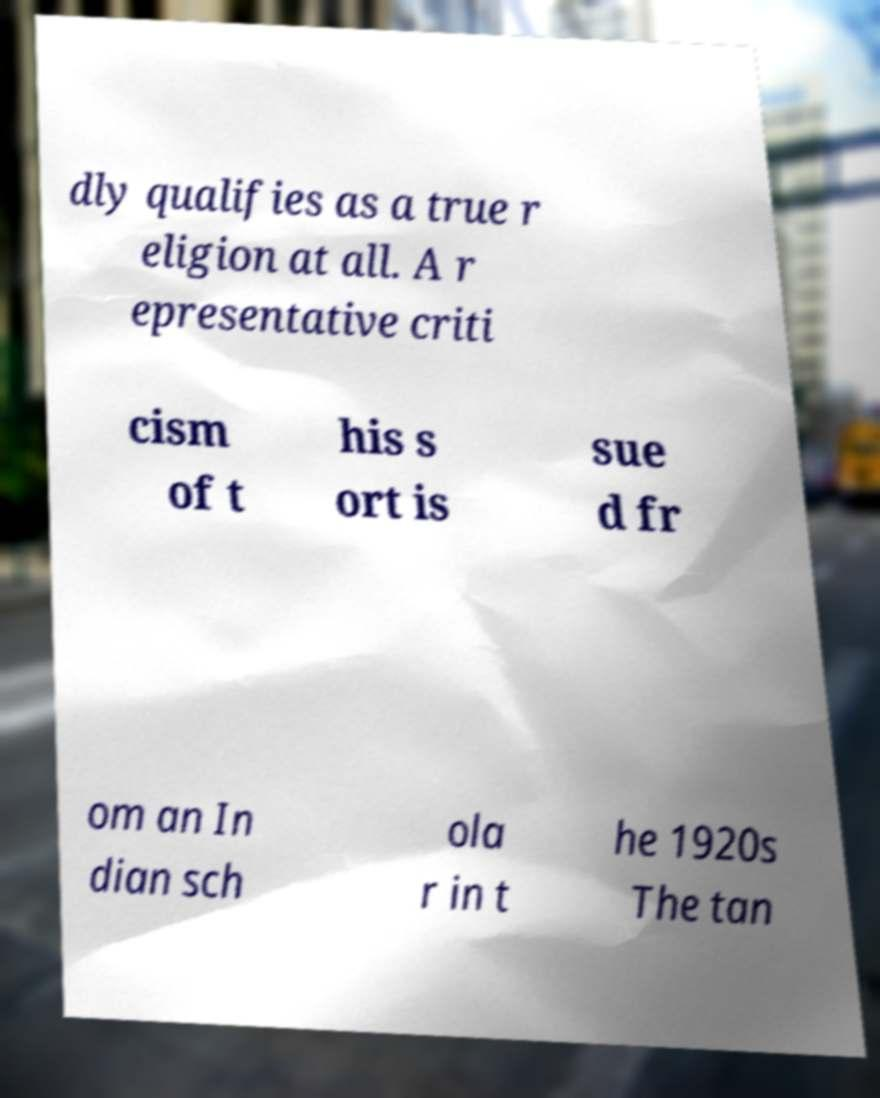Could you extract and type out the text from this image? dly qualifies as a true r eligion at all. A r epresentative criti cism of t his s ort is sue d fr om an In dian sch ola r in t he 1920s The tan 